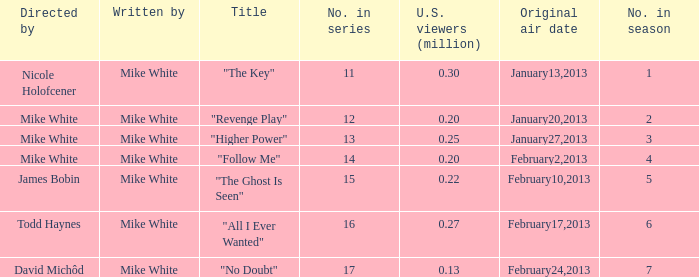How many episodes in the serie were title "the key" 1.0. 